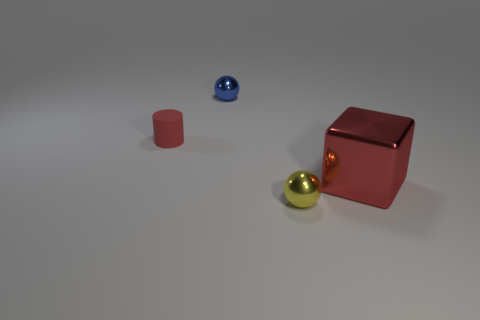Add 1 metal spheres. How many objects exist? 5 Subtract all blocks. How many objects are left? 3 Subtract 0 blue cylinders. How many objects are left? 4 Subtract all metal things. Subtract all cylinders. How many objects are left? 0 Add 2 red metallic cubes. How many red metallic cubes are left? 3 Add 3 blue objects. How many blue objects exist? 4 